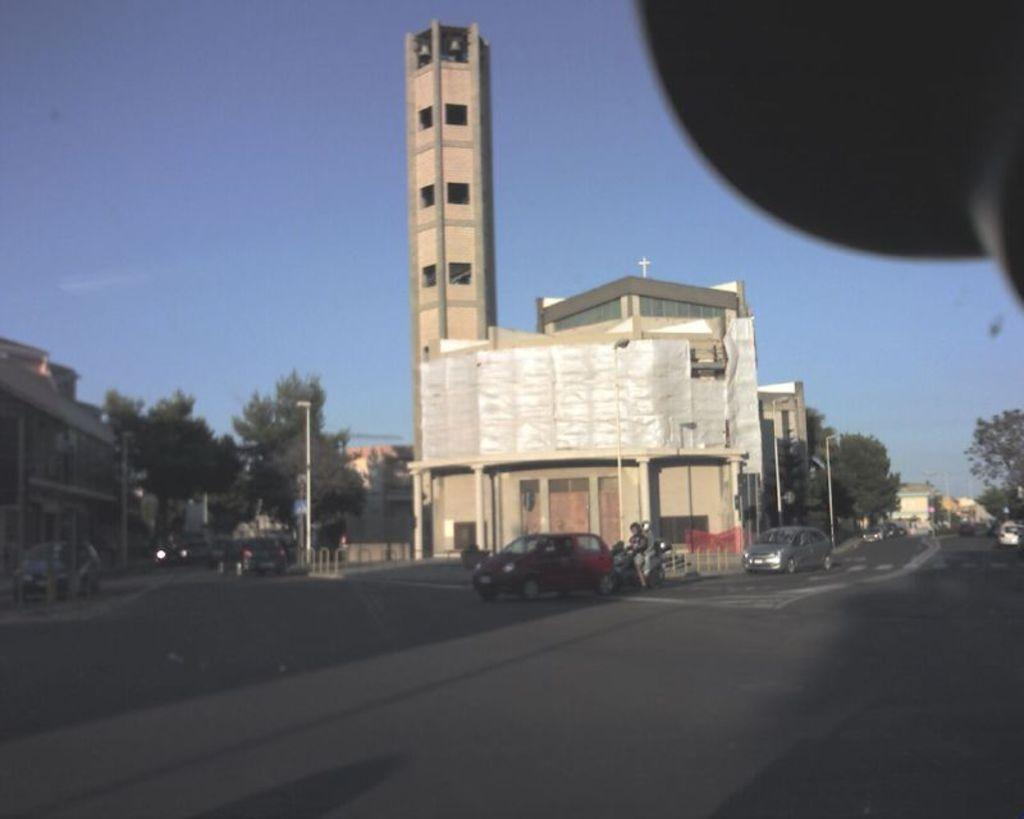What is the tall structure in the image? There is a tall tower in the image. What is the tower located near? The tower is beside a church. What can be seen happening on the road in front of the church? There are vehicles moving on the road in front of the church. What type of vegetation is on the left side of the image? There are trees on the left side of the image. What type of dress is the tower wearing in the image? The tower is not a living being and therefore cannot wear a dress. How does the wind blow the trees on the left side of the image? The image does not show the wind blowing the trees; it only shows the trees as they are. 